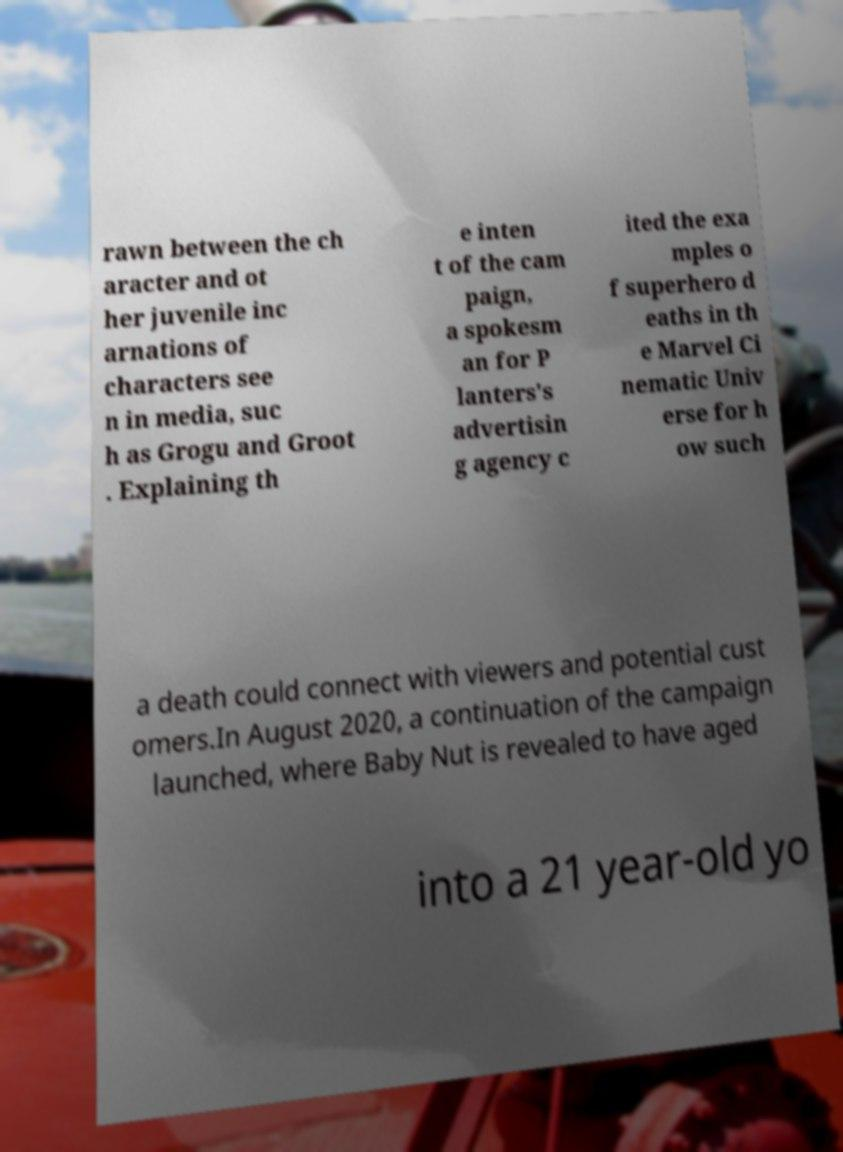There's text embedded in this image that I need extracted. Can you transcribe it verbatim? rawn between the ch aracter and ot her juvenile inc arnations of characters see n in media, suc h as Grogu and Groot . Explaining th e inten t of the cam paign, a spokesm an for P lanters's advertisin g agency c ited the exa mples o f superhero d eaths in th e Marvel Ci nematic Univ erse for h ow such a death could connect with viewers and potential cust omers.In August 2020, a continuation of the campaign launched, where Baby Nut is revealed to have aged into a 21 year-old yo 